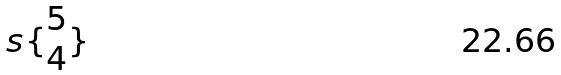<formula> <loc_0><loc_0><loc_500><loc_500>s \{ \begin{matrix} 5 \\ 4 \end{matrix} \}</formula> 